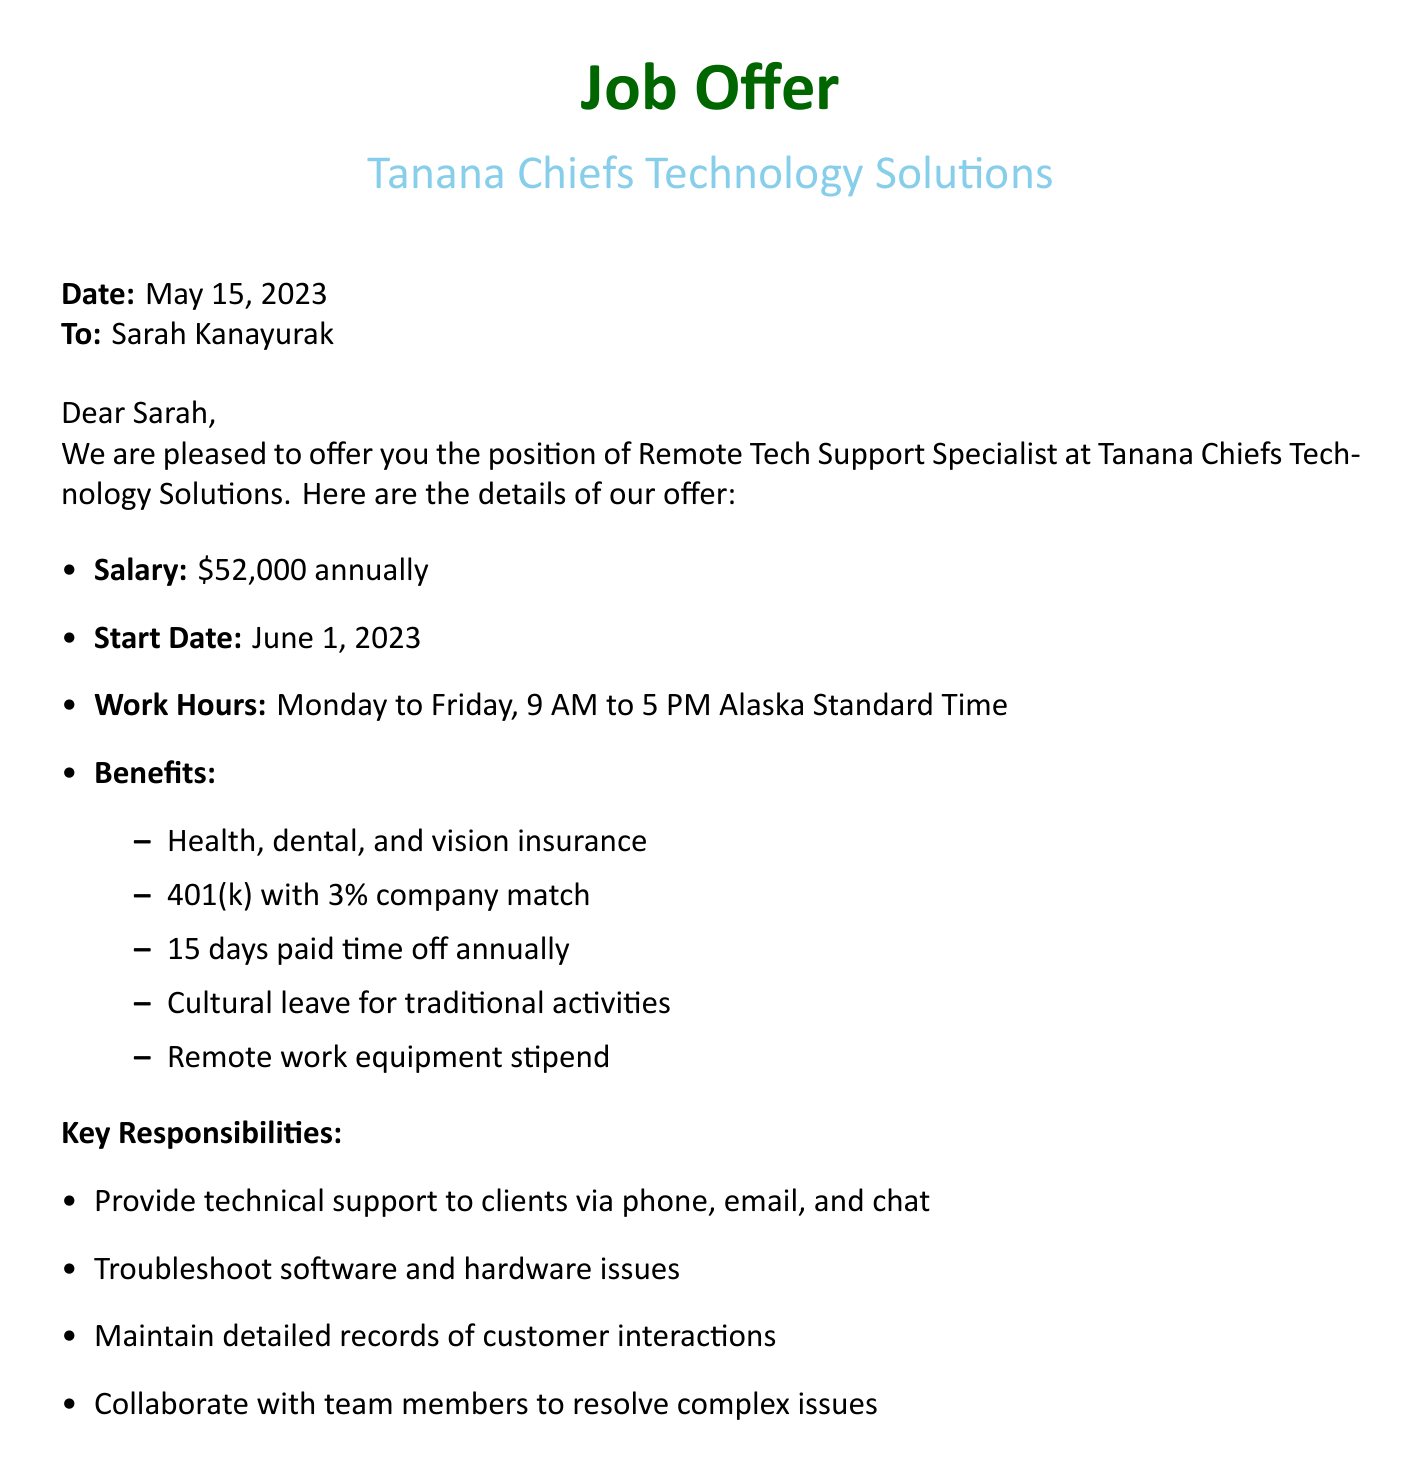what is the job title offered? The job title is explicitly stated in the document as Remote Tech Support Specialist.
Answer: Remote Tech Support Specialist what is the annual salary for the position? The salary is mentioned directly in the document as \$52,000 annually.
Answer: \$52,000 annually what is the start date of the employment? The start date is provided in the document as June 1, 2023.
Answer: June 1, 2023 how many days of paid time off are provided? The document states that there are 15 days paid time off annually.
Answer: 15 days who is the HR Manager to contact for questions? The HR Manager’s name is listed in the document as John Silas.
Answer: John Silas what are the work hours for the position? The work hours are specified as Monday to Friday, 9 AM to 5 PM Alaska Standard Time.
Answer: Monday to Friday, 9 AM to 5 PM Alaska Standard Time what type of insurance is included in the benefits? The benefits include health, dental, and vision insurance, as listed in the document.
Answer: health, dental, and vision insurance what is the cultural leave provided for? The document states that cultural leave is for traditional activities.
Answer: traditional activities 